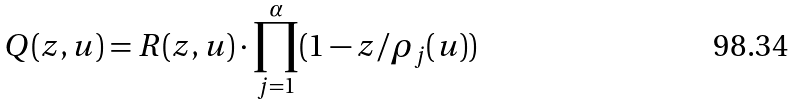<formula> <loc_0><loc_0><loc_500><loc_500>Q ( z , { u } ) = R ( z , { u } ) \cdot \prod _ { j = 1 } ^ { \alpha } ( 1 - z / \rho _ { j } ( { u } ) )</formula> 